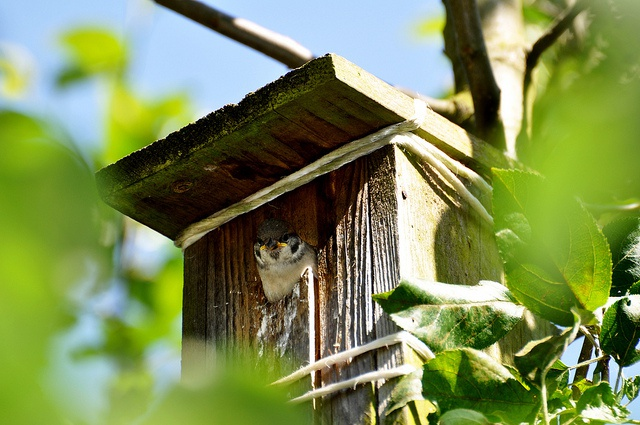Describe the objects in this image and their specific colors. I can see a bird in lightblue, black, tan, gray, and olive tones in this image. 